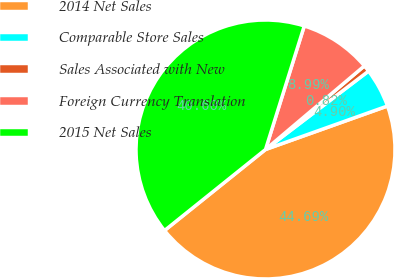<chart> <loc_0><loc_0><loc_500><loc_500><pie_chart><fcel>2014 Net Sales<fcel>Comparable Store Sales<fcel>Sales Associated with New<fcel>Foreign Currency Translation<fcel>2015 Net Sales<nl><fcel>44.69%<fcel>4.9%<fcel>0.82%<fcel>8.99%<fcel>40.6%<nl></chart> 